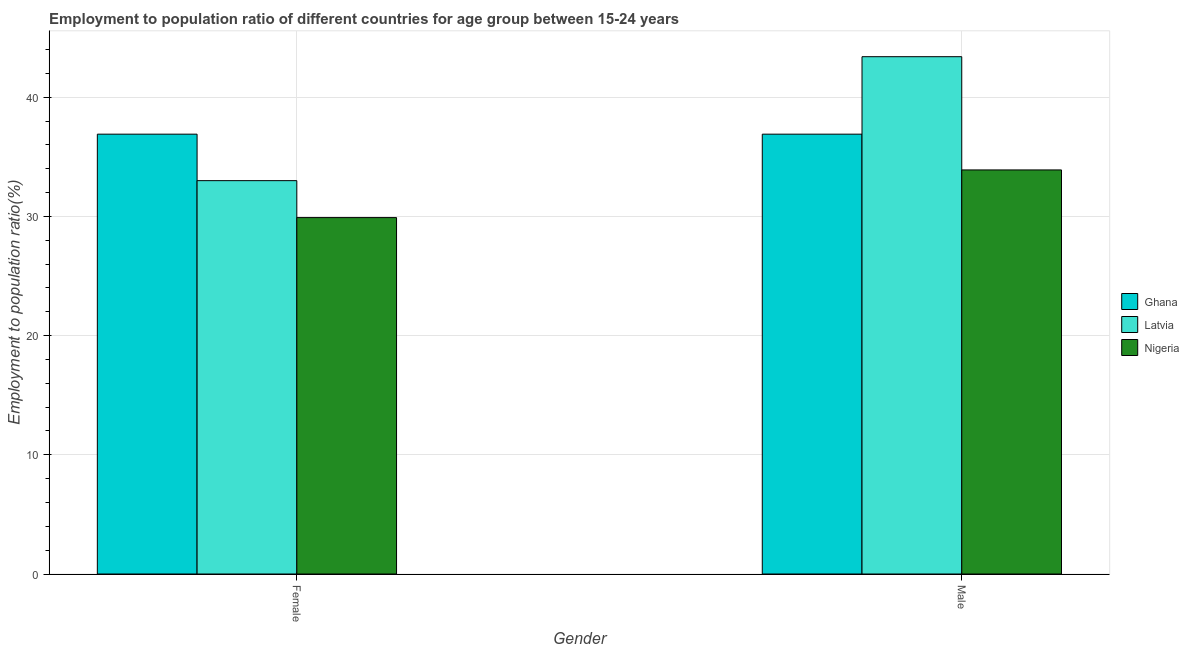How many groups of bars are there?
Ensure brevity in your answer.  2. What is the employment to population ratio(female) in Ghana?
Provide a short and direct response. 36.9. Across all countries, what is the maximum employment to population ratio(male)?
Offer a terse response. 43.4. Across all countries, what is the minimum employment to population ratio(female)?
Give a very brief answer. 29.9. In which country was the employment to population ratio(female) maximum?
Keep it short and to the point. Ghana. In which country was the employment to population ratio(female) minimum?
Keep it short and to the point. Nigeria. What is the total employment to population ratio(male) in the graph?
Provide a short and direct response. 114.2. What is the difference between the employment to population ratio(male) in Ghana and the employment to population ratio(female) in Nigeria?
Make the answer very short. 7. What is the average employment to population ratio(female) per country?
Give a very brief answer. 33.27. What is the difference between the employment to population ratio(female) and employment to population ratio(male) in Nigeria?
Give a very brief answer. -4. What is the ratio of the employment to population ratio(male) in Nigeria to that in Ghana?
Your answer should be compact. 0.92. Is the employment to population ratio(female) in Latvia less than that in Nigeria?
Keep it short and to the point. No. What does the 3rd bar from the left in Female represents?
Your answer should be compact. Nigeria. What does the 2nd bar from the right in Male represents?
Keep it short and to the point. Latvia. How many bars are there?
Offer a terse response. 6. What is the difference between two consecutive major ticks on the Y-axis?
Give a very brief answer. 10. Are the values on the major ticks of Y-axis written in scientific E-notation?
Give a very brief answer. No. Does the graph contain any zero values?
Give a very brief answer. No. Where does the legend appear in the graph?
Provide a short and direct response. Center right. How are the legend labels stacked?
Offer a very short reply. Vertical. What is the title of the graph?
Make the answer very short. Employment to population ratio of different countries for age group between 15-24 years. Does "Equatorial Guinea" appear as one of the legend labels in the graph?
Give a very brief answer. No. What is the label or title of the X-axis?
Your answer should be compact. Gender. What is the label or title of the Y-axis?
Provide a succinct answer. Employment to population ratio(%). What is the Employment to population ratio(%) in Ghana in Female?
Offer a very short reply. 36.9. What is the Employment to population ratio(%) in Latvia in Female?
Provide a succinct answer. 33. What is the Employment to population ratio(%) of Nigeria in Female?
Ensure brevity in your answer.  29.9. What is the Employment to population ratio(%) in Ghana in Male?
Ensure brevity in your answer.  36.9. What is the Employment to population ratio(%) of Latvia in Male?
Your answer should be very brief. 43.4. What is the Employment to population ratio(%) of Nigeria in Male?
Provide a succinct answer. 33.9. Across all Gender, what is the maximum Employment to population ratio(%) of Ghana?
Offer a very short reply. 36.9. Across all Gender, what is the maximum Employment to population ratio(%) in Latvia?
Keep it short and to the point. 43.4. Across all Gender, what is the maximum Employment to population ratio(%) in Nigeria?
Provide a short and direct response. 33.9. Across all Gender, what is the minimum Employment to population ratio(%) of Ghana?
Keep it short and to the point. 36.9. Across all Gender, what is the minimum Employment to population ratio(%) in Nigeria?
Offer a terse response. 29.9. What is the total Employment to population ratio(%) in Ghana in the graph?
Your answer should be compact. 73.8. What is the total Employment to population ratio(%) of Latvia in the graph?
Offer a terse response. 76.4. What is the total Employment to population ratio(%) in Nigeria in the graph?
Your answer should be compact. 63.8. What is the difference between the Employment to population ratio(%) in Latvia in Female and that in Male?
Keep it short and to the point. -10.4. What is the difference between the Employment to population ratio(%) of Ghana in Female and the Employment to population ratio(%) of Latvia in Male?
Make the answer very short. -6.5. What is the difference between the Employment to population ratio(%) of Ghana in Female and the Employment to population ratio(%) of Nigeria in Male?
Keep it short and to the point. 3. What is the difference between the Employment to population ratio(%) in Latvia in Female and the Employment to population ratio(%) in Nigeria in Male?
Your response must be concise. -0.9. What is the average Employment to population ratio(%) in Ghana per Gender?
Provide a succinct answer. 36.9. What is the average Employment to population ratio(%) of Latvia per Gender?
Your answer should be very brief. 38.2. What is the average Employment to population ratio(%) in Nigeria per Gender?
Provide a succinct answer. 31.9. What is the difference between the Employment to population ratio(%) in Latvia and Employment to population ratio(%) in Nigeria in Female?
Your answer should be very brief. 3.1. What is the difference between the Employment to population ratio(%) in Latvia and Employment to population ratio(%) in Nigeria in Male?
Provide a short and direct response. 9.5. What is the ratio of the Employment to population ratio(%) of Latvia in Female to that in Male?
Ensure brevity in your answer.  0.76. What is the ratio of the Employment to population ratio(%) of Nigeria in Female to that in Male?
Offer a terse response. 0.88. What is the difference between the highest and the second highest Employment to population ratio(%) of Latvia?
Keep it short and to the point. 10.4. What is the difference between the highest and the second highest Employment to population ratio(%) of Nigeria?
Keep it short and to the point. 4. What is the difference between the highest and the lowest Employment to population ratio(%) of Ghana?
Provide a succinct answer. 0. What is the difference between the highest and the lowest Employment to population ratio(%) of Latvia?
Your answer should be compact. 10.4. 